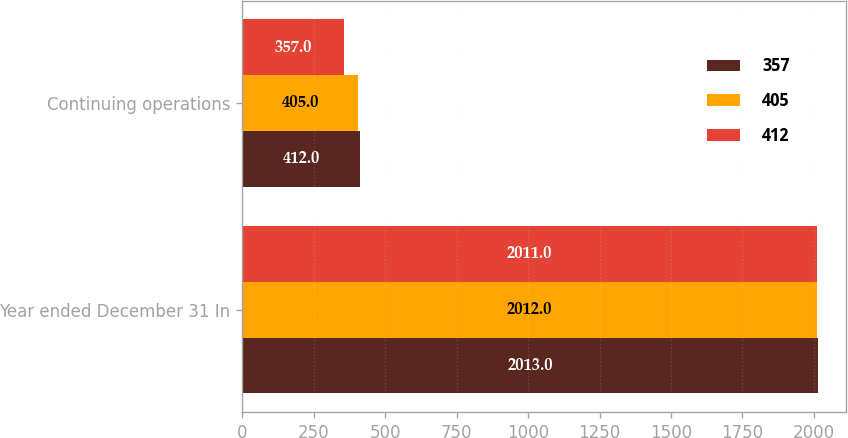Convert chart. <chart><loc_0><loc_0><loc_500><loc_500><stacked_bar_chart><ecel><fcel>Year ended December 31 In<fcel>Continuing operations<nl><fcel>357<fcel>2013<fcel>412<nl><fcel>405<fcel>2012<fcel>405<nl><fcel>412<fcel>2011<fcel>357<nl></chart> 